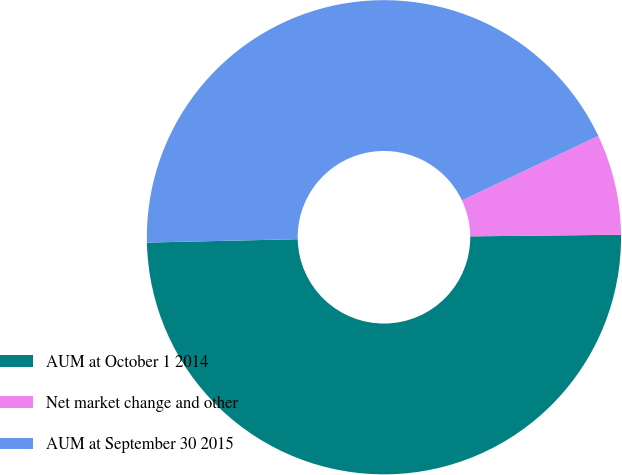Convert chart. <chart><loc_0><loc_0><loc_500><loc_500><pie_chart><fcel>AUM at October 1 2014<fcel>Net market change and other<fcel>AUM at September 30 2015<nl><fcel>49.81%<fcel>6.86%<fcel>43.33%<nl></chart> 